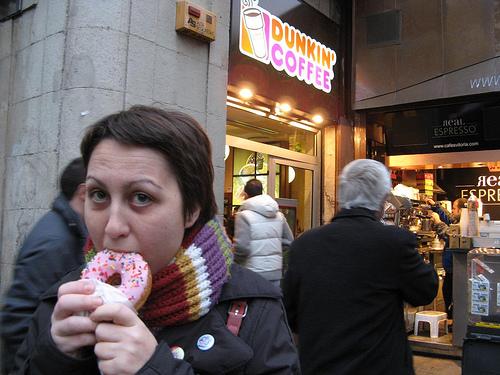Is it summer?
Concise answer only. No. Where did the lady buy the donut from?
Answer briefly. Dunkin' coffee. What is the woman wearing around her neck?
Answer briefly. Scarf. 